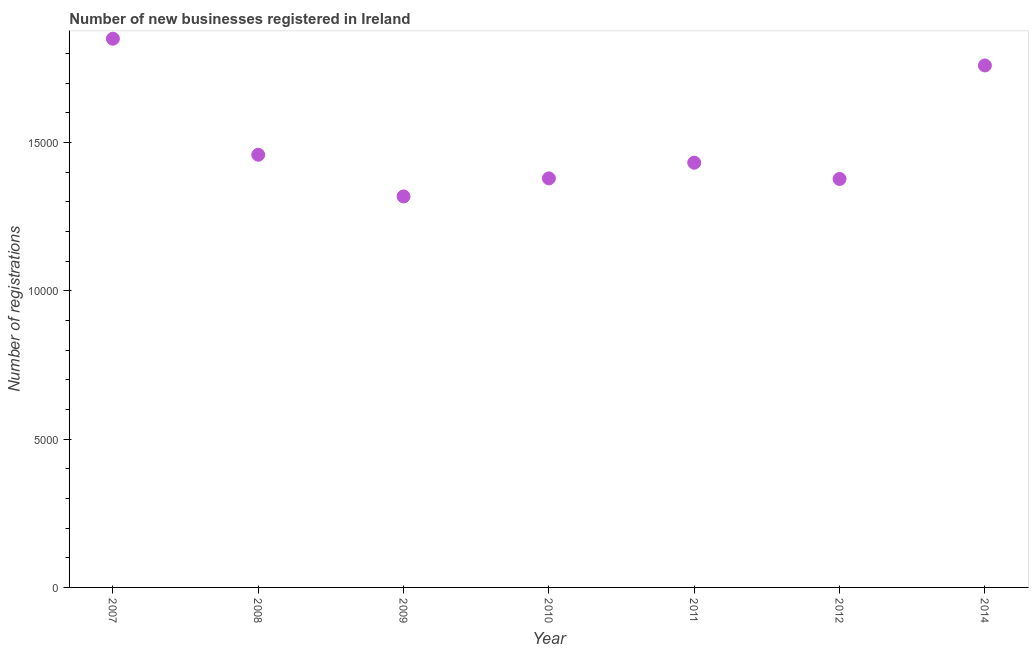What is the number of new business registrations in 2011?
Keep it short and to the point. 1.43e+04. Across all years, what is the maximum number of new business registrations?
Your response must be concise. 1.85e+04. Across all years, what is the minimum number of new business registrations?
Ensure brevity in your answer.  1.32e+04. In which year was the number of new business registrations maximum?
Your response must be concise. 2007. In which year was the number of new business registrations minimum?
Keep it short and to the point. 2009. What is the sum of the number of new business registrations?
Your answer should be very brief. 1.06e+05. What is the difference between the number of new business registrations in 2008 and 2012?
Offer a terse response. 816. What is the average number of new business registrations per year?
Keep it short and to the point. 1.51e+04. What is the median number of new business registrations?
Keep it short and to the point. 1.43e+04. In how many years, is the number of new business registrations greater than 3000 ?
Provide a succinct answer. 7. Do a majority of the years between 2011 and 2008 (inclusive) have number of new business registrations greater than 5000 ?
Your answer should be compact. Yes. What is the ratio of the number of new business registrations in 2007 to that in 2012?
Offer a terse response. 1.34. Is the number of new business registrations in 2008 less than that in 2010?
Your answer should be compact. No. Is the difference between the number of new business registrations in 2011 and 2012 greater than the difference between any two years?
Ensure brevity in your answer.  No. What is the difference between the highest and the second highest number of new business registrations?
Your answer should be very brief. 902. What is the difference between the highest and the lowest number of new business registrations?
Your response must be concise. 5318. In how many years, is the number of new business registrations greater than the average number of new business registrations taken over all years?
Offer a very short reply. 2. What is the title of the graph?
Offer a terse response. Number of new businesses registered in Ireland. What is the label or title of the Y-axis?
Make the answer very short. Number of registrations. What is the Number of registrations in 2007?
Keep it short and to the point. 1.85e+04. What is the Number of registrations in 2008?
Ensure brevity in your answer.  1.46e+04. What is the Number of registrations in 2009?
Ensure brevity in your answer.  1.32e+04. What is the Number of registrations in 2010?
Give a very brief answer. 1.38e+04. What is the Number of registrations in 2011?
Provide a succinct answer. 1.43e+04. What is the Number of registrations in 2012?
Offer a terse response. 1.38e+04. What is the Number of registrations in 2014?
Provide a short and direct response. 1.76e+04. What is the difference between the Number of registrations in 2007 and 2008?
Offer a terse response. 3913. What is the difference between the Number of registrations in 2007 and 2009?
Your response must be concise. 5318. What is the difference between the Number of registrations in 2007 and 2010?
Your answer should be very brief. 4710. What is the difference between the Number of registrations in 2007 and 2011?
Give a very brief answer. 4181. What is the difference between the Number of registrations in 2007 and 2012?
Provide a short and direct response. 4729. What is the difference between the Number of registrations in 2007 and 2014?
Your answer should be compact. 902. What is the difference between the Number of registrations in 2008 and 2009?
Keep it short and to the point. 1405. What is the difference between the Number of registrations in 2008 and 2010?
Your answer should be very brief. 797. What is the difference between the Number of registrations in 2008 and 2011?
Offer a very short reply. 268. What is the difference between the Number of registrations in 2008 and 2012?
Keep it short and to the point. 816. What is the difference between the Number of registrations in 2008 and 2014?
Your response must be concise. -3011. What is the difference between the Number of registrations in 2009 and 2010?
Provide a succinct answer. -608. What is the difference between the Number of registrations in 2009 and 2011?
Provide a succinct answer. -1137. What is the difference between the Number of registrations in 2009 and 2012?
Your answer should be very brief. -589. What is the difference between the Number of registrations in 2009 and 2014?
Offer a very short reply. -4416. What is the difference between the Number of registrations in 2010 and 2011?
Your answer should be compact. -529. What is the difference between the Number of registrations in 2010 and 2014?
Keep it short and to the point. -3808. What is the difference between the Number of registrations in 2011 and 2012?
Make the answer very short. 548. What is the difference between the Number of registrations in 2011 and 2014?
Keep it short and to the point. -3279. What is the difference between the Number of registrations in 2012 and 2014?
Keep it short and to the point. -3827. What is the ratio of the Number of registrations in 2007 to that in 2008?
Your response must be concise. 1.27. What is the ratio of the Number of registrations in 2007 to that in 2009?
Give a very brief answer. 1.4. What is the ratio of the Number of registrations in 2007 to that in 2010?
Keep it short and to the point. 1.34. What is the ratio of the Number of registrations in 2007 to that in 2011?
Your response must be concise. 1.29. What is the ratio of the Number of registrations in 2007 to that in 2012?
Your answer should be compact. 1.34. What is the ratio of the Number of registrations in 2007 to that in 2014?
Your answer should be very brief. 1.05. What is the ratio of the Number of registrations in 2008 to that in 2009?
Your answer should be very brief. 1.11. What is the ratio of the Number of registrations in 2008 to that in 2010?
Provide a short and direct response. 1.06. What is the ratio of the Number of registrations in 2008 to that in 2011?
Your answer should be compact. 1.02. What is the ratio of the Number of registrations in 2008 to that in 2012?
Make the answer very short. 1.06. What is the ratio of the Number of registrations in 2008 to that in 2014?
Offer a very short reply. 0.83. What is the ratio of the Number of registrations in 2009 to that in 2010?
Your response must be concise. 0.96. What is the ratio of the Number of registrations in 2009 to that in 2011?
Your answer should be very brief. 0.92. What is the ratio of the Number of registrations in 2009 to that in 2014?
Your response must be concise. 0.75. What is the ratio of the Number of registrations in 2010 to that in 2011?
Provide a short and direct response. 0.96. What is the ratio of the Number of registrations in 2010 to that in 2014?
Keep it short and to the point. 0.78. What is the ratio of the Number of registrations in 2011 to that in 2012?
Your answer should be very brief. 1.04. What is the ratio of the Number of registrations in 2011 to that in 2014?
Your response must be concise. 0.81. What is the ratio of the Number of registrations in 2012 to that in 2014?
Your response must be concise. 0.78. 